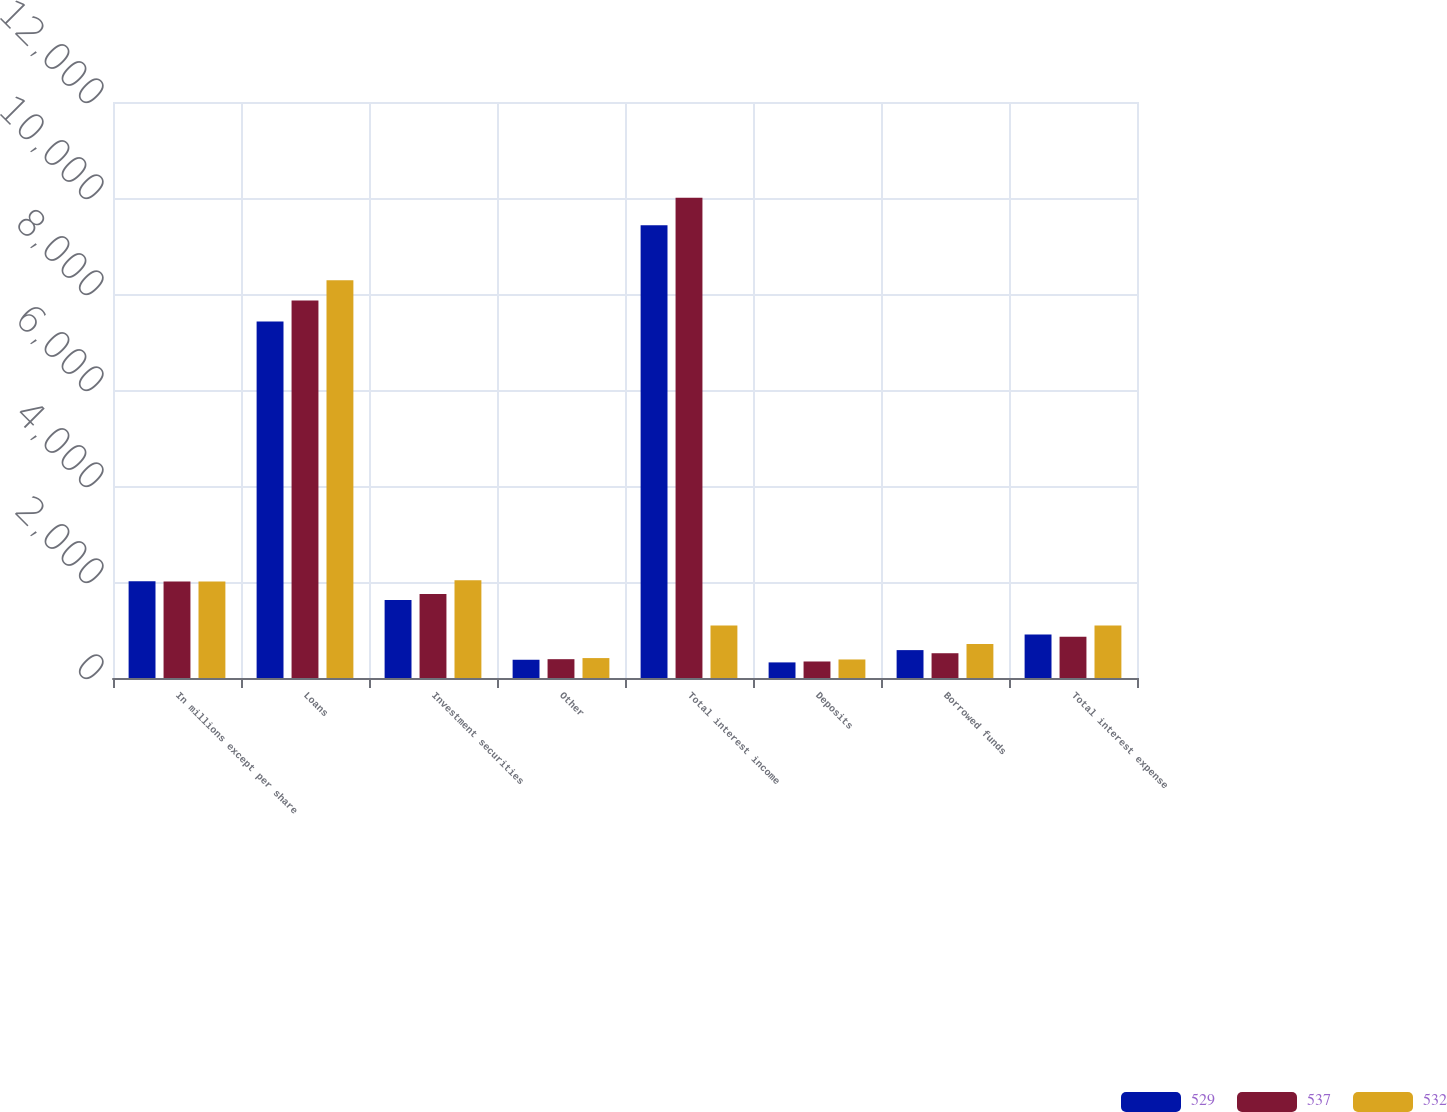Convert chart to OTSL. <chart><loc_0><loc_0><loc_500><loc_500><stacked_bar_chart><ecel><fcel>In millions except per share<fcel>Loans<fcel>Investment securities<fcel>Other<fcel>Total interest income<fcel>Deposits<fcel>Borrowed funds<fcel>Total interest expense<nl><fcel>529<fcel>2014<fcel>7427<fcel>1624<fcel>380<fcel>9431<fcel>325<fcel>581<fcel>906<nl><fcel>537<fcel>2013<fcel>7866<fcel>1749<fcel>392<fcel>10007<fcel>344<fcel>516<fcel>860<nl><fcel>532<fcel>2012<fcel>8284<fcel>2035<fcel>415<fcel>1094<fcel>386<fcel>708<fcel>1094<nl></chart> 